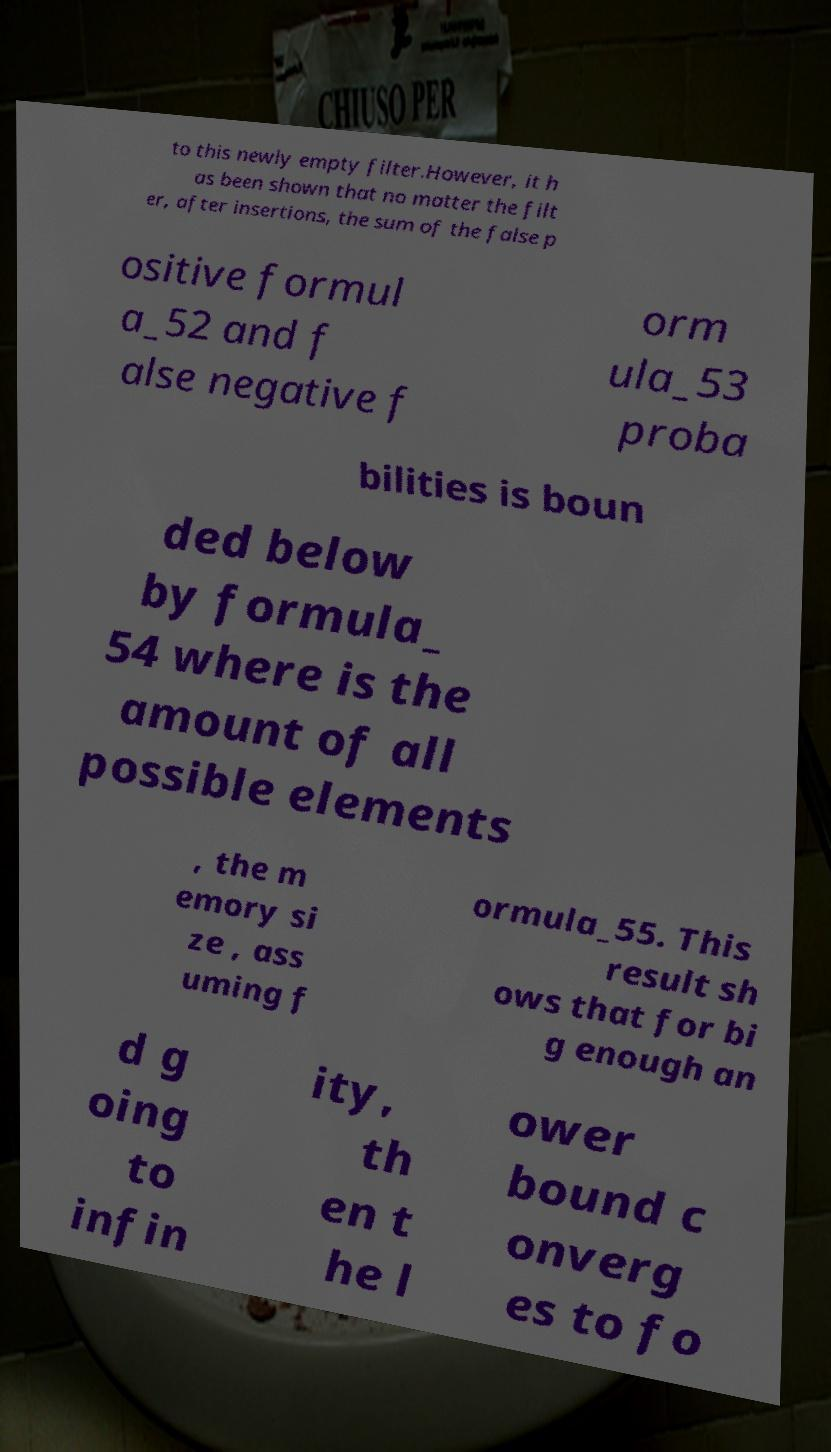I need the written content from this picture converted into text. Can you do that? to this newly empty filter.However, it h as been shown that no matter the filt er, after insertions, the sum of the false p ositive formul a_52 and f alse negative f orm ula_53 proba bilities is boun ded below by formula_ 54 where is the amount of all possible elements , the m emory si ze , ass uming f ormula_55. This result sh ows that for bi g enough an d g oing to infin ity, th en t he l ower bound c onverg es to fo 